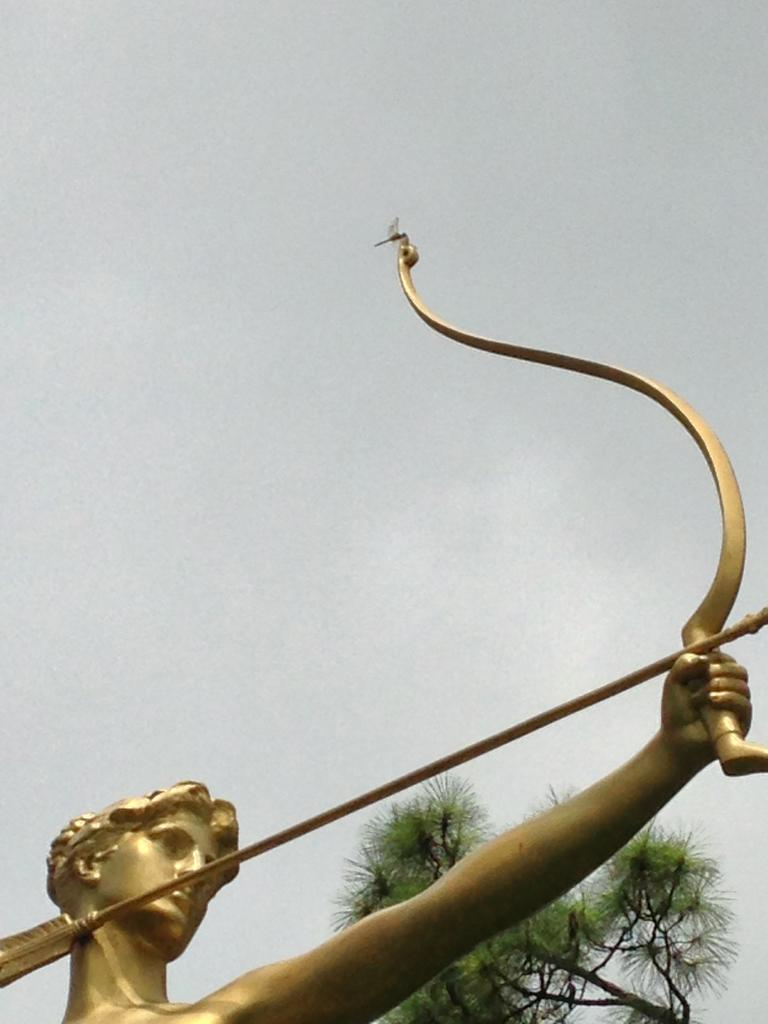What is the main subject of the image? The image appears to depict the sky. Are there any objects or figures at the bottom of the image? Yes, there is a sculpture of a person holding a bow and arrow at the bottom of the image. What other elements can be seen in the image? There is a tree in the image. What color is the underwear worn by the person holding the bow and arrow in the image? There is no person wearing underwear in the image, as it is a sculpture of a person holding a bow and arrow. 